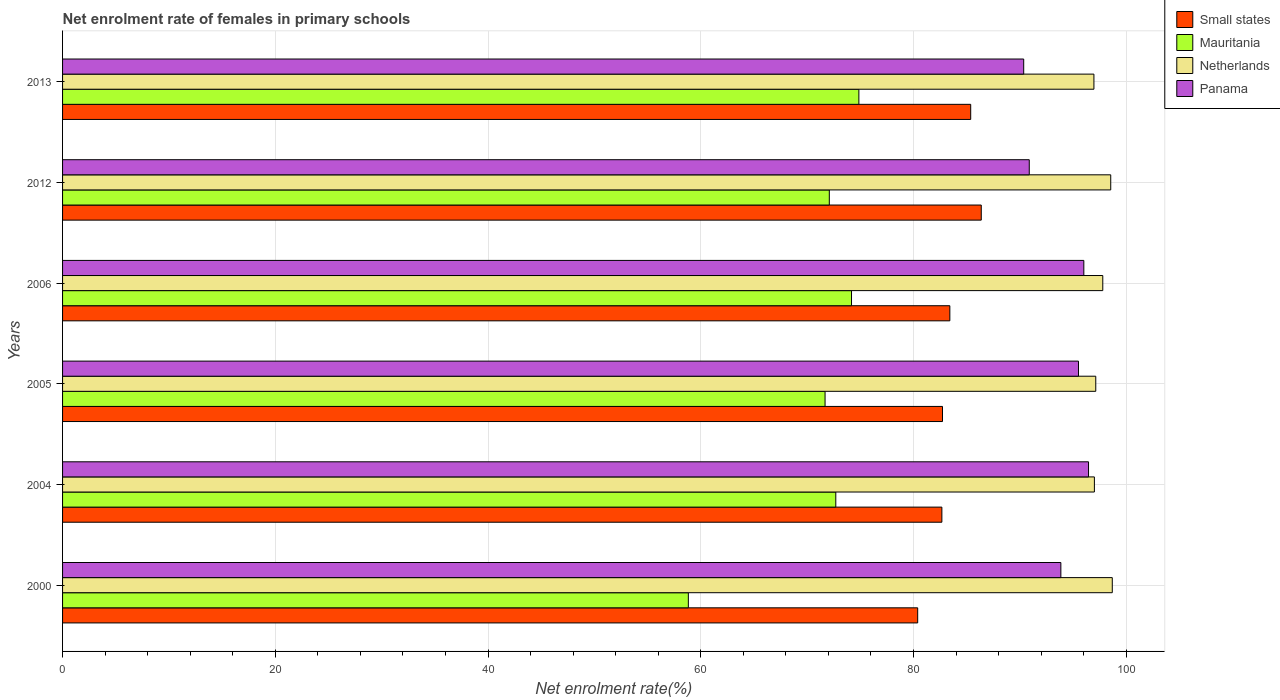How many different coloured bars are there?
Offer a terse response. 4. How many bars are there on the 5th tick from the top?
Provide a succinct answer. 4. How many bars are there on the 5th tick from the bottom?
Keep it short and to the point. 4. In how many cases, is the number of bars for a given year not equal to the number of legend labels?
Your response must be concise. 0. What is the net enrolment rate of females in primary schools in Small states in 2004?
Give a very brief answer. 82.67. Across all years, what is the maximum net enrolment rate of females in primary schools in Panama?
Your answer should be compact. 96.46. Across all years, what is the minimum net enrolment rate of females in primary schools in Netherlands?
Offer a terse response. 96.97. What is the total net enrolment rate of females in primary schools in Panama in the graph?
Ensure brevity in your answer.  563.11. What is the difference between the net enrolment rate of females in primary schools in Panama in 2004 and that in 2012?
Your answer should be very brief. 5.57. What is the difference between the net enrolment rate of females in primary schools in Panama in 2004 and the net enrolment rate of females in primary schools in Small states in 2005?
Offer a very short reply. 13.73. What is the average net enrolment rate of females in primary schools in Panama per year?
Keep it short and to the point. 93.85. In the year 2013, what is the difference between the net enrolment rate of females in primary schools in Netherlands and net enrolment rate of females in primary schools in Small states?
Offer a very short reply. 11.59. What is the ratio of the net enrolment rate of females in primary schools in Panama in 2012 to that in 2013?
Your answer should be very brief. 1.01. What is the difference between the highest and the second highest net enrolment rate of females in primary schools in Small states?
Provide a succinct answer. 0.99. What is the difference between the highest and the lowest net enrolment rate of females in primary schools in Small states?
Your answer should be very brief. 5.98. In how many years, is the net enrolment rate of females in primary schools in Small states greater than the average net enrolment rate of females in primary schools in Small states taken over all years?
Keep it short and to the point. 2. What does the 1st bar from the top in 2000 represents?
Your response must be concise. Panama. What does the 3rd bar from the bottom in 2013 represents?
Offer a terse response. Netherlands. How many bars are there?
Your answer should be compact. 24. How many years are there in the graph?
Ensure brevity in your answer.  6. Does the graph contain any zero values?
Ensure brevity in your answer.  No. Does the graph contain grids?
Provide a succinct answer. Yes. Where does the legend appear in the graph?
Offer a very short reply. Top right. How many legend labels are there?
Offer a very short reply. 4. How are the legend labels stacked?
Make the answer very short. Vertical. What is the title of the graph?
Keep it short and to the point. Net enrolment rate of females in primary schools. What is the label or title of the X-axis?
Make the answer very short. Net enrolment rate(%). What is the Net enrolment rate(%) in Small states in 2000?
Offer a very short reply. 80.4. What is the Net enrolment rate(%) of Mauritania in 2000?
Provide a short and direct response. 58.84. What is the Net enrolment rate(%) in Netherlands in 2000?
Provide a short and direct response. 98.69. What is the Net enrolment rate(%) in Panama in 2000?
Ensure brevity in your answer.  93.86. What is the Net enrolment rate(%) in Small states in 2004?
Make the answer very short. 82.67. What is the Net enrolment rate(%) in Mauritania in 2004?
Ensure brevity in your answer.  72.7. What is the Net enrolment rate(%) in Netherlands in 2004?
Offer a terse response. 97.01. What is the Net enrolment rate(%) in Panama in 2004?
Offer a terse response. 96.46. What is the Net enrolment rate(%) in Small states in 2005?
Give a very brief answer. 82.73. What is the Net enrolment rate(%) of Mauritania in 2005?
Ensure brevity in your answer.  71.69. What is the Net enrolment rate(%) in Netherlands in 2005?
Your answer should be compact. 97.14. What is the Net enrolment rate(%) of Panama in 2005?
Provide a succinct answer. 95.52. What is the Net enrolment rate(%) of Small states in 2006?
Ensure brevity in your answer.  83.42. What is the Net enrolment rate(%) of Mauritania in 2006?
Offer a very short reply. 74.18. What is the Net enrolment rate(%) in Netherlands in 2006?
Ensure brevity in your answer.  97.8. What is the Net enrolment rate(%) in Panama in 2006?
Ensure brevity in your answer.  96.02. What is the Net enrolment rate(%) of Small states in 2012?
Keep it short and to the point. 86.37. What is the Net enrolment rate(%) in Mauritania in 2012?
Offer a terse response. 72.09. What is the Net enrolment rate(%) in Netherlands in 2012?
Provide a short and direct response. 98.55. What is the Net enrolment rate(%) in Panama in 2012?
Provide a short and direct response. 90.89. What is the Net enrolment rate(%) in Small states in 2013?
Provide a short and direct response. 85.38. What is the Net enrolment rate(%) in Mauritania in 2013?
Your answer should be compact. 74.87. What is the Net enrolment rate(%) of Netherlands in 2013?
Make the answer very short. 96.97. What is the Net enrolment rate(%) in Panama in 2013?
Give a very brief answer. 90.37. Across all years, what is the maximum Net enrolment rate(%) in Small states?
Your answer should be compact. 86.37. Across all years, what is the maximum Net enrolment rate(%) of Mauritania?
Ensure brevity in your answer.  74.87. Across all years, what is the maximum Net enrolment rate(%) of Netherlands?
Ensure brevity in your answer.  98.69. Across all years, what is the maximum Net enrolment rate(%) in Panama?
Provide a succinct answer. 96.46. Across all years, what is the minimum Net enrolment rate(%) in Small states?
Keep it short and to the point. 80.4. Across all years, what is the minimum Net enrolment rate(%) of Mauritania?
Offer a very short reply. 58.84. Across all years, what is the minimum Net enrolment rate(%) of Netherlands?
Your answer should be very brief. 96.97. Across all years, what is the minimum Net enrolment rate(%) of Panama?
Give a very brief answer. 90.37. What is the total Net enrolment rate(%) of Small states in the graph?
Your response must be concise. 500.98. What is the total Net enrolment rate(%) of Mauritania in the graph?
Your response must be concise. 424.36. What is the total Net enrolment rate(%) of Netherlands in the graph?
Offer a very short reply. 586.16. What is the total Net enrolment rate(%) in Panama in the graph?
Your answer should be compact. 563.11. What is the difference between the Net enrolment rate(%) of Small states in 2000 and that in 2004?
Give a very brief answer. -2.27. What is the difference between the Net enrolment rate(%) of Mauritania in 2000 and that in 2004?
Make the answer very short. -13.86. What is the difference between the Net enrolment rate(%) of Netherlands in 2000 and that in 2004?
Give a very brief answer. 1.68. What is the difference between the Net enrolment rate(%) of Panama in 2000 and that in 2004?
Make the answer very short. -2.6. What is the difference between the Net enrolment rate(%) in Small states in 2000 and that in 2005?
Give a very brief answer. -2.33. What is the difference between the Net enrolment rate(%) of Mauritania in 2000 and that in 2005?
Keep it short and to the point. -12.85. What is the difference between the Net enrolment rate(%) of Netherlands in 2000 and that in 2005?
Give a very brief answer. 1.55. What is the difference between the Net enrolment rate(%) of Panama in 2000 and that in 2005?
Your answer should be compact. -1.66. What is the difference between the Net enrolment rate(%) of Small states in 2000 and that in 2006?
Your answer should be compact. -3.02. What is the difference between the Net enrolment rate(%) in Mauritania in 2000 and that in 2006?
Offer a terse response. -15.34. What is the difference between the Net enrolment rate(%) in Netherlands in 2000 and that in 2006?
Provide a succinct answer. 0.89. What is the difference between the Net enrolment rate(%) in Panama in 2000 and that in 2006?
Make the answer very short. -2.16. What is the difference between the Net enrolment rate(%) of Small states in 2000 and that in 2012?
Your answer should be compact. -5.98. What is the difference between the Net enrolment rate(%) of Mauritania in 2000 and that in 2012?
Your answer should be very brief. -13.25. What is the difference between the Net enrolment rate(%) in Netherlands in 2000 and that in 2012?
Your answer should be very brief. 0.15. What is the difference between the Net enrolment rate(%) of Panama in 2000 and that in 2012?
Keep it short and to the point. 2.97. What is the difference between the Net enrolment rate(%) in Small states in 2000 and that in 2013?
Make the answer very short. -4.98. What is the difference between the Net enrolment rate(%) in Mauritania in 2000 and that in 2013?
Provide a succinct answer. -16.03. What is the difference between the Net enrolment rate(%) in Netherlands in 2000 and that in 2013?
Your response must be concise. 1.73. What is the difference between the Net enrolment rate(%) of Panama in 2000 and that in 2013?
Your response must be concise. 3.49. What is the difference between the Net enrolment rate(%) in Small states in 2004 and that in 2005?
Your answer should be very brief. -0.06. What is the difference between the Net enrolment rate(%) of Mauritania in 2004 and that in 2005?
Provide a short and direct response. 1.01. What is the difference between the Net enrolment rate(%) of Netherlands in 2004 and that in 2005?
Your answer should be very brief. -0.13. What is the difference between the Net enrolment rate(%) of Small states in 2004 and that in 2006?
Make the answer very short. -0.75. What is the difference between the Net enrolment rate(%) of Mauritania in 2004 and that in 2006?
Your response must be concise. -1.48. What is the difference between the Net enrolment rate(%) in Netherlands in 2004 and that in 2006?
Your answer should be compact. -0.79. What is the difference between the Net enrolment rate(%) in Panama in 2004 and that in 2006?
Offer a very short reply. 0.44. What is the difference between the Net enrolment rate(%) of Small states in 2004 and that in 2012?
Your answer should be very brief. -3.7. What is the difference between the Net enrolment rate(%) in Mauritania in 2004 and that in 2012?
Your answer should be compact. 0.61. What is the difference between the Net enrolment rate(%) of Netherlands in 2004 and that in 2012?
Keep it short and to the point. -1.54. What is the difference between the Net enrolment rate(%) of Panama in 2004 and that in 2012?
Your answer should be very brief. 5.57. What is the difference between the Net enrolment rate(%) of Small states in 2004 and that in 2013?
Give a very brief answer. -2.71. What is the difference between the Net enrolment rate(%) in Mauritania in 2004 and that in 2013?
Provide a succinct answer. -2.17. What is the difference between the Net enrolment rate(%) of Netherlands in 2004 and that in 2013?
Offer a very short reply. 0.04. What is the difference between the Net enrolment rate(%) of Panama in 2004 and that in 2013?
Your answer should be very brief. 6.09. What is the difference between the Net enrolment rate(%) in Small states in 2005 and that in 2006?
Make the answer very short. -0.69. What is the difference between the Net enrolment rate(%) in Mauritania in 2005 and that in 2006?
Provide a succinct answer. -2.49. What is the difference between the Net enrolment rate(%) of Netherlands in 2005 and that in 2006?
Your response must be concise. -0.66. What is the difference between the Net enrolment rate(%) in Panama in 2005 and that in 2006?
Give a very brief answer. -0.5. What is the difference between the Net enrolment rate(%) in Small states in 2005 and that in 2012?
Your answer should be very brief. -3.64. What is the difference between the Net enrolment rate(%) of Mauritania in 2005 and that in 2012?
Give a very brief answer. -0.4. What is the difference between the Net enrolment rate(%) of Netherlands in 2005 and that in 2012?
Offer a terse response. -1.41. What is the difference between the Net enrolment rate(%) of Panama in 2005 and that in 2012?
Keep it short and to the point. 4.63. What is the difference between the Net enrolment rate(%) in Small states in 2005 and that in 2013?
Keep it short and to the point. -2.65. What is the difference between the Net enrolment rate(%) of Mauritania in 2005 and that in 2013?
Ensure brevity in your answer.  -3.18. What is the difference between the Net enrolment rate(%) of Netherlands in 2005 and that in 2013?
Give a very brief answer. 0.17. What is the difference between the Net enrolment rate(%) of Panama in 2005 and that in 2013?
Give a very brief answer. 5.15. What is the difference between the Net enrolment rate(%) of Small states in 2006 and that in 2012?
Offer a terse response. -2.95. What is the difference between the Net enrolment rate(%) in Mauritania in 2006 and that in 2012?
Offer a terse response. 2.09. What is the difference between the Net enrolment rate(%) of Netherlands in 2006 and that in 2012?
Give a very brief answer. -0.75. What is the difference between the Net enrolment rate(%) of Panama in 2006 and that in 2012?
Ensure brevity in your answer.  5.13. What is the difference between the Net enrolment rate(%) in Small states in 2006 and that in 2013?
Ensure brevity in your answer.  -1.96. What is the difference between the Net enrolment rate(%) of Mauritania in 2006 and that in 2013?
Give a very brief answer. -0.69. What is the difference between the Net enrolment rate(%) of Netherlands in 2006 and that in 2013?
Make the answer very short. 0.83. What is the difference between the Net enrolment rate(%) of Panama in 2006 and that in 2013?
Keep it short and to the point. 5.65. What is the difference between the Net enrolment rate(%) of Mauritania in 2012 and that in 2013?
Provide a succinct answer. -2.78. What is the difference between the Net enrolment rate(%) in Netherlands in 2012 and that in 2013?
Keep it short and to the point. 1.58. What is the difference between the Net enrolment rate(%) of Panama in 2012 and that in 2013?
Offer a very short reply. 0.52. What is the difference between the Net enrolment rate(%) in Small states in 2000 and the Net enrolment rate(%) in Mauritania in 2004?
Make the answer very short. 7.7. What is the difference between the Net enrolment rate(%) in Small states in 2000 and the Net enrolment rate(%) in Netherlands in 2004?
Keep it short and to the point. -16.61. What is the difference between the Net enrolment rate(%) in Small states in 2000 and the Net enrolment rate(%) in Panama in 2004?
Make the answer very short. -16.06. What is the difference between the Net enrolment rate(%) of Mauritania in 2000 and the Net enrolment rate(%) of Netherlands in 2004?
Give a very brief answer. -38.18. What is the difference between the Net enrolment rate(%) in Mauritania in 2000 and the Net enrolment rate(%) in Panama in 2004?
Your response must be concise. -37.62. What is the difference between the Net enrolment rate(%) in Netherlands in 2000 and the Net enrolment rate(%) in Panama in 2004?
Your response must be concise. 2.23. What is the difference between the Net enrolment rate(%) of Small states in 2000 and the Net enrolment rate(%) of Mauritania in 2005?
Your answer should be compact. 8.71. What is the difference between the Net enrolment rate(%) of Small states in 2000 and the Net enrolment rate(%) of Netherlands in 2005?
Make the answer very short. -16.74. What is the difference between the Net enrolment rate(%) in Small states in 2000 and the Net enrolment rate(%) in Panama in 2005?
Provide a succinct answer. -15.12. What is the difference between the Net enrolment rate(%) in Mauritania in 2000 and the Net enrolment rate(%) in Netherlands in 2005?
Provide a short and direct response. -38.31. What is the difference between the Net enrolment rate(%) of Mauritania in 2000 and the Net enrolment rate(%) of Panama in 2005?
Offer a very short reply. -36.68. What is the difference between the Net enrolment rate(%) of Netherlands in 2000 and the Net enrolment rate(%) of Panama in 2005?
Your response must be concise. 3.18. What is the difference between the Net enrolment rate(%) of Small states in 2000 and the Net enrolment rate(%) of Mauritania in 2006?
Give a very brief answer. 6.22. What is the difference between the Net enrolment rate(%) in Small states in 2000 and the Net enrolment rate(%) in Netherlands in 2006?
Make the answer very short. -17.4. What is the difference between the Net enrolment rate(%) in Small states in 2000 and the Net enrolment rate(%) in Panama in 2006?
Offer a very short reply. -15.62. What is the difference between the Net enrolment rate(%) of Mauritania in 2000 and the Net enrolment rate(%) of Netherlands in 2006?
Provide a short and direct response. -38.97. What is the difference between the Net enrolment rate(%) in Mauritania in 2000 and the Net enrolment rate(%) in Panama in 2006?
Your response must be concise. -37.18. What is the difference between the Net enrolment rate(%) in Netherlands in 2000 and the Net enrolment rate(%) in Panama in 2006?
Your answer should be compact. 2.68. What is the difference between the Net enrolment rate(%) of Small states in 2000 and the Net enrolment rate(%) of Mauritania in 2012?
Make the answer very short. 8.31. What is the difference between the Net enrolment rate(%) of Small states in 2000 and the Net enrolment rate(%) of Netherlands in 2012?
Provide a succinct answer. -18.15. What is the difference between the Net enrolment rate(%) in Small states in 2000 and the Net enrolment rate(%) in Panama in 2012?
Offer a very short reply. -10.49. What is the difference between the Net enrolment rate(%) in Mauritania in 2000 and the Net enrolment rate(%) in Netherlands in 2012?
Your answer should be very brief. -39.71. What is the difference between the Net enrolment rate(%) of Mauritania in 2000 and the Net enrolment rate(%) of Panama in 2012?
Provide a short and direct response. -32.05. What is the difference between the Net enrolment rate(%) of Netherlands in 2000 and the Net enrolment rate(%) of Panama in 2012?
Ensure brevity in your answer.  7.81. What is the difference between the Net enrolment rate(%) in Small states in 2000 and the Net enrolment rate(%) in Mauritania in 2013?
Provide a succinct answer. 5.53. What is the difference between the Net enrolment rate(%) of Small states in 2000 and the Net enrolment rate(%) of Netherlands in 2013?
Make the answer very short. -16.57. What is the difference between the Net enrolment rate(%) in Small states in 2000 and the Net enrolment rate(%) in Panama in 2013?
Your answer should be very brief. -9.97. What is the difference between the Net enrolment rate(%) in Mauritania in 2000 and the Net enrolment rate(%) in Netherlands in 2013?
Ensure brevity in your answer.  -38.13. What is the difference between the Net enrolment rate(%) in Mauritania in 2000 and the Net enrolment rate(%) in Panama in 2013?
Keep it short and to the point. -31.53. What is the difference between the Net enrolment rate(%) in Netherlands in 2000 and the Net enrolment rate(%) in Panama in 2013?
Your answer should be compact. 8.33. What is the difference between the Net enrolment rate(%) in Small states in 2004 and the Net enrolment rate(%) in Mauritania in 2005?
Provide a short and direct response. 10.98. What is the difference between the Net enrolment rate(%) in Small states in 2004 and the Net enrolment rate(%) in Netherlands in 2005?
Your answer should be compact. -14.47. What is the difference between the Net enrolment rate(%) of Small states in 2004 and the Net enrolment rate(%) of Panama in 2005?
Your answer should be very brief. -12.84. What is the difference between the Net enrolment rate(%) of Mauritania in 2004 and the Net enrolment rate(%) of Netherlands in 2005?
Your response must be concise. -24.44. What is the difference between the Net enrolment rate(%) of Mauritania in 2004 and the Net enrolment rate(%) of Panama in 2005?
Ensure brevity in your answer.  -22.82. What is the difference between the Net enrolment rate(%) of Netherlands in 2004 and the Net enrolment rate(%) of Panama in 2005?
Make the answer very short. 1.5. What is the difference between the Net enrolment rate(%) of Small states in 2004 and the Net enrolment rate(%) of Mauritania in 2006?
Provide a short and direct response. 8.5. What is the difference between the Net enrolment rate(%) in Small states in 2004 and the Net enrolment rate(%) in Netherlands in 2006?
Offer a terse response. -15.13. What is the difference between the Net enrolment rate(%) of Small states in 2004 and the Net enrolment rate(%) of Panama in 2006?
Your answer should be compact. -13.35. What is the difference between the Net enrolment rate(%) of Mauritania in 2004 and the Net enrolment rate(%) of Netherlands in 2006?
Your answer should be compact. -25.1. What is the difference between the Net enrolment rate(%) of Mauritania in 2004 and the Net enrolment rate(%) of Panama in 2006?
Offer a very short reply. -23.32. What is the difference between the Net enrolment rate(%) in Netherlands in 2004 and the Net enrolment rate(%) in Panama in 2006?
Keep it short and to the point. 0.99. What is the difference between the Net enrolment rate(%) of Small states in 2004 and the Net enrolment rate(%) of Mauritania in 2012?
Make the answer very short. 10.58. What is the difference between the Net enrolment rate(%) in Small states in 2004 and the Net enrolment rate(%) in Netherlands in 2012?
Provide a short and direct response. -15.88. What is the difference between the Net enrolment rate(%) of Small states in 2004 and the Net enrolment rate(%) of Panama in 2012?
Give a very brief answer. -8.22. What is the difference between the Net enrolment rate(%) of Mauritania in 2004 and the Net enrolment rate(%) of Netherlands in 2012?
Offer a terse response. -25.85. What is the difference between the Net enrolment rate(%) in Mauritania in 2004 and the Net enrolment rate(%) in Panama in 2012?
Keep it short and to the point. -18.19. What is the difference between the Net enrolment rate(%) in Netherlands in 2004 and the Net enrolment rate(%) in Panama in 2012?
Ensure brevity in your answer.  6.12. What is the difference between the Net enrolment rate(%) in Small states in 2004 and the Net enrolment rate(%) in Mauritania in 2013?
Your response must be concise. 7.8. What is the difference between the Net enrolment rate(%) of Small states in 2004 and the Net enrolment rate(%) of Netherlands in 2013?
Offer a very short reply. -14.3. What is the difference between the Net enrolment rate(%) in Small states in 2004 and the Net enrolment rate(%) in Panama in 2013?
Offer a very short reply. -7.69. What is the difference between the Net enrolment rate(%) of Mauritania in 2004 and the Net enrolment rate(%) of Netherlands in 2013?
Make the answer very short. -24.27. What is the difference between the Net enrolment rate(%) in Mauritania in 2004 and the Net enrolment rate(%) in Panama in 2013?
Ensure brevity in your answer.  -17.67. What is the difference between the Net enrolment rate(%) of Netherlands in 2004 and the Net enrolment rate(%) of Panama in 2013?
Keep it short and to the point. 6.65. What is the difference between the Net enrolment rate(%) of Small states in 2005 and the Net enrolment rate(%) of Mauritania in 2006?
Your answer should be very brief. 8.55. What is the difference between the Net enrolment rate(%) in Small states in 2005 and the Net enrolment rate(%) in Netherlands in 2006?
Keep it short and to the point. -15.07. What is the difference between the Net enrolment rate(%) of Small states in 2005 and the Net enrolment rate(%) of Panama in 2006?
Offer a very short reply. -13.29. What is the difference between the Net enrolment rate(%) of Mauritania in 2005 and the Net enrolment rate(%) of Netherlands in 2006?
Offer a terse response. -26.11. What is the difference between the Net enrolment rate(%) in Mauritania in 2005 and the Net enrolment rate(%) in Panama in 2006?
Offer a terse response. -24.33. What is the difference between the Net enrolment rate(%) of Netherlands in 2005 and the Net enrolment rate(%) of Panama in 2006?
Offer a very short reply. 1.12. What is the difference between the Net enrolment rate(%) in Small states in 2005 and the Net enrolment rate(%) in Mauritania in 2012?
Keep it short and to the point. 10.64. What is the difference between the Net enrolment rate(%) of Small states in 2005 and the Net enrolment rate(%) of Netherlands in 2012?
Offer a terse response. -15.82. What is the difference between the Net enrolment rate(%) in Small states in 2005 and the Net enrolment rate(%) in Panama in 2012?
Provide a succinct answer. -8.16. What is the difference between the Net enrolment rate(%) of Mauritania in 2005 and the Net enrolment rate(%) of Netherlands in 2012?
Provide a short and direct response. -26.86. What is the difference between the Net enrolment rate(%) in Mauritania in 2005 and the Net enrolment rate(%) in Panama in 2012?
Your answer should be compact. -19.2. What is the difference between the Net enrolment rate(%) of Netherlands in 2005 and the Net enrolment rate(%) of Panama in 2012?
Offer a very short reply. 6.25. What is the difference between the Net enrolment rate(%) in Small states in 2005 and the Net enrolment rate(%) in Mauritania in 2013?
Give a very brief answer. 7.86. What is the difference between the Net enrolment rate(%) in Small states in 2005 and the Net enrolment rate(%) in Netherlands in 2013?
Your response must be concise. -14.24. What is the difference between the Net enrolment rate(%) of Small states in 2005 and the Net enrolment rate(%) of Panama in 2013?
Keep it short and to the point. -7.63. What is the difference between the Net enrolment rate(%) in Mauritania in 2005 and the Net enrolment rate(%) in Netherlands in 2013?
Provide a succinct answer. -25.28. What is the difference between the Net enrolment rate(%) in Mauritania in 2005 and the Net enrolment rate(%) in Panama in 2013?
Give a very brief answer. -18.68. What is the difference between the Net enrolment rate(%) of Netherlands in 2005 and the Net enrolment rate(%) of Panama in 2013?
Your answer should be compact. 6.78. What is the difference between the Net enrolment rate(%) in Small states in 2006 and the Net enrolment rate(%) in Mauritania in 2012?
Provide a succinct answer. 11.33. What is the difference between the Net enrolment rate(%) of Small states in 2006 and the Net enrolment rate(%) of Netherlands in 2012?
Make the answer very short. -15.13. What is the difference between the Net enrolment rate(%) in Small states in 2006 and the Net enrolment rate(%) in Panama in 2012?
Your answer should be compact. -7.47. What is the difference between the Net enrolment rate(%) of Mauritania in 2006 and the Net enrolment rate(%) of Netherlands in 2012?
Make the answer very short. -24.37. What is the difference between the Net enrolment rate(%) of Mauritania in 2006 and the Net enrolment rate(%) of Panama in 2012?
Provide a short and direct response. -16.71. What is the difference between the Net enrolment rate(%) in Netherlands in 2006 and the Net enrolment rate(%) in Panama in 2012?
Your answer should be very brief. 6.91. What is the difference between the Net enrolment rate(%) in Small states in 2006 and the Net enrolment rate(%) in Mauritania in 2013?
Provide a succinct answer. 8.55. What is the difference between the Net enrolment rate(%) of Small states in 2006 and the Net enrolment rate(%) of Netherlands in 2013?
Provide a short and direct response. -13.55. What is the difference between the Net enrolment rate(%) of Small states in 2006 and the Net enrolment rate(%) of Panama in 2013?
Offer a terse response. -6.94. What is the difference between the Net enrolment rate(%) of Mauritania in 2006 and the Net enrolment rate(%) of Netherlands in 2013?
Your answer should be compact. -22.79. What is the difference between the Net enrolment rate(%) of Mauritania in 2006 and the Net enrolment rate(%) of Panama in 2013?
Keep it short and to the point. -16.19. What is the difference between the Net enrolment rate(%) in Netherlands in 2006 and the Net enrolment rate(%) in Panama in 2013?
Offer a very short reply. 7.44. What is the difference between the Net enrolment rate(%) of Small states in 2012 and the Net enrolment rate(%) of Mauritania in 2013?
Give a very brief answer. 11.51. What is the difference between the Net enrolment rate(%) in Small states in 2012 and the Net enrolment rate(%) in Netherlands in 2013?
Offer a very short reply. -10.59. What is the difference between the Net enrolment rate(%) in Small states in 2012 and the Net enrolment rate(%) in Panama in 2013?
Provide a succinct answer. -3.99. What is the difference between the Net enrolment rate(%) in Mauritania in 2012 and the Net enrolment rate(%) in Netherlands in 2013?
Your answer should be compact. -24.88. What is the difference between the Net enrolment rate(%) in Mauritania in 2012 and the Net enrolment rate(%) in Panama in 2013?
Your response must be concise. -18.28. What is the difference between the Net enrolment rate(%) in Netherlands in 2012 and the Net enrolment rate(%) in Panama in 2013?
Give a very brief answer. 8.18. What is the average Net enrolment rate(%) in Small states per year?
Offer a terse response. 83.5. What is the average Net enrolment rate(%) in Mauritania per year?
Offer a terse response. 70.73. What is the average Net enrolment rate(%) in Netherlands per year?
Offer a very short reply. 97.69. What is the average Net enrolment rate(%) of Panama per year?
Keep it short and to the point. 93.85. In the year 2000, what is the difference between the Net enrolment rate(%) of Small states and Net enrolment rate(%) of Mauritania?
Keep it short and to the point. 21.56. In the year 2000, what is the difference between the Net enrolment rate(%) of Small states and Net enrolment rate(%) of Netherlands?
Give a very brief answer. -18.3. In the year 2000, what is the difference between the Net enrolment rate(%) of Small states and Net enrolment rate(%) of Panama?
Keep it short and to the point. -13.46. In the year 2000, what is the difference between the Net enrolment rate(%) of Mauritania and Net enrolment rate(%) of Netherlands?
Make the answer very short. -39.86. In the year 2000, what is the difference between the Net enrolment rate(%) of Mauritania and Net enrolment rate(%) of Panama?
Make the answer very short. -35.02. In the year 2000, what is the difference between the Net enrolment rate(%) in Netherlands and Net enrolment rate(%) in Panama?
Your answer should be very brief. 4.84. In the year 2004, what is the difference between the Net enrolment rate(%) of Small states and Net enrolment rate(%) of Mauritania?
Your answer should be very brief. 9.97. In the year 2004, what is the difference between the Net enrolment rate(%) of Small states and Net enrolment rate(%) of Netherlands?
Your response must be concise. -14.34. In the year 2004, what is the difference between the Net enrolment rate(%) in Small states and Net enrolment rate(%) in Panama?
Give a very brief answer. -13.79. In the year 2004, what is the difference between the Net enrolment rate(%) in Mauritania and Net enrolment rate(%) in Netherlands?
Ensure brevity in your answer.  -24.31. In the year 2004, what is the difference between the Net enrolment rate(%) of Mauritania and Net enrolment rate(%) of Panama?
Provide a succinct answer. -23.76. In the year 2004, what is the difference between the Net enrolment rate(%) of Netherlands and Net enrolment rate(%) of Panama?
Offer a terse response. 0.55. In the year 2005, what is the difference between the Net enrolment rate(%) of Small states and Net enrolment rate(%) of Mauritania?
Give a very brief answer. 11.04. In the year 2005, what is the difference between the Net enrolment rate(%) in Small states and Net enrolment rate(%) in Netherlands?
Offer a very short reply. -14.41. In the year 2005, what is the difference between the Net enrolment rate(%) of Small states and Net enrolment rate(%) of Panama?
Provide a succinct answer. -12.79. In the year 2005, what is the difference between the Net enrolment rate(%) of Mauritania and Net enrolment rate(%) of Netherlands?
Offer a terse response. -25.45. In the year 2005, what is the difference between the Net enrolment rate(%) of Mauritania and Net enrolment rate(%) of Panama?
Your answer should be very brief. -23.83. In the year 2005, what is the difference between the Net enrolment rate(%) of Netherlands and Net enrolment rate(%) of Panama?
Your response must be concise. 1.63. In the year 2006, what is the difference between the Net enrolment rate(%) of Small states and Net enrolment rate(%) of Mauritania?
Make the answer very short. 9.25. In the year 2006, what is the difference between the Net enrolment rate(%) in Small states and Net enrolment rate(%) in Netherlands?
Provide a succinct answer. -14.38. In the year 2006, what is the difference between the Net enrolment rate(%) of Small states and Net enrolment rate(%) of Panama?
Ensure brevity in your answer.  -12.6. In the year 2006, what is the difference between the Net enrolment rate(%) in Mauritania and Net enrolment rate(%) in Netherlands?
Offer a terse response. -23.62. In the year 2006, what is the difference between the Net enrolment rate(%) in Mauritania and Net enrolment rate(%) in Panama?
Offer a terse response. -21.84. In the year 2006, what is the difference between the Net enrolment rate(%) in Netherlands and Net enrolment rate(%) in Panama?
Ensure brevity in your answer.  1.78. In the year 2012, what is the difference between the Net enrolment rate(%) in Small states and Net enrolment rate(%) in Mauritania?
Give a very brief answer. 14.29. In the year 2012, what is the difference between the Net enrolment rate(%) in Small states and Net enrolment rate(%) in Netherlands?
Provide a succinct answer. -12.17. In the year 2012, what is the difference between the Net enrolment rate(%) in Small states and Net enrolment rate(%) in Panama?
Provide a succinct answer. -4.51. In the year 2012, what is the difference between the Net enrolment rate(%) of Mauritania and Net enrolment rate(%) of Netherlands?
Ensure brevity in your answer.  -26.46. In the year 2012, what is the difference between the Net enrolment rate(%) of Mauritania and Net enrolment rate(%) of Panama?
Make the answer very short. -18.8. In the year 2012, what is the difference between the Net enrolment rate(%) in Netherlands and Net enrolment rate(%) in Panama?
Provide a succinct answer. 7.66. In the year 2013, what is the difference between the Net enrolment rate(%) in Small states and Net enrolment rate(%) in Mauritania?
Give a very brief answer. 10.51. In the year 2013, what is the difference between the Net enrolment rate(%) of Small states and Net enrolment rate(%) of Netherlands?
Your answer should be very brief. -11.59. In the year 2013, what is the difference between the Net enrolment rate(%) of Small states and Net enrolment rate(%) of Panama?
Your answer should be compact. -4.98. In the year 2013, what is the difference between the Net enrolment rate(%) in Mauritania and Net enrolment rate(%) in Netherlands?
Provide a short and direct response. -22.1. In the year 2013, what is the difference between the Net enrolment rate(%) in Mauritania and Net enrolment rate(%) in Panama?
Provide a short and direct response. -15.5. In the year 2013, what is the difference between the Net enrolment rate(%) in Netherlands and Net enrolment rate(%) in Panama?
Give a very brief answer. 6.6. What is the ratio of the Net enrolment rate(%) of Small states in 2000 to that in 2004?
Provide a succinct answer. 0.97. What is the ratio of the Net enrolment rate(%) of Mauritania in 2000 to that in 2004?
Ensure brevity in your answer.  0.81. What is the ratio of the Net enrolment rate(%) of Netherlands in 2000 to that in 2004?
Provide a succinct answer. 1.02. What is the ratio of the Net enrolment rate(%) in Small states in 2000 to that in 2005?
Offer a terse response. 0.97. What is the ratio of the Net enrolment rate(%) in Mauritania in 2000 to that in 2005?
Your response must be concise. 0.82. What is the ratio of the Net enrolment rate(%) of Netherlands in 2000 to that in 2005?
Offer a terse response. 1.02. What is the ratio of the Net enrolment rate(%) of Panama in 2000 to that in 2005?
Your response must be concise. 0.98. What is the ratio of the Net enrolment rate(%) in Small states in 2000 to that in 2006?
Offer a terse response. 0.96. What is the ratio of the Net enrolment rate(%) in Mauritania in 2000 to that in 2006?
Your response must be concise. 0.79. What is the ratio of the Net enrolment rate(%) of Netherlands in 2000 to that in 2006?
Ensure brevity in your answer.  1.01. What is the ratio of the Net enrolment rate(%) of Panama in 2000 to that in 2006?
Your answer should be compact. 0.98. What is the ratio of the Net enrolment rate(%) in Small states in 2000 to that in 2012?
Provide a succinct answer. 0.93. What is the ratio of the Net enrolment rate(%) in Mauritania in 2000 to that in 2012?
Your answer should be very brief. 0.82. What is the ratio of the Net enrolment rate(%) of Panama in 2000 to that in 2012?
Your answer should be very brief. 1.03. What is the ratio of the Net enrolment rate(%) in Small states in 2000 to that in 2013?
Your answer should be compact. 0.94. What is the ratio of the Net enrolment rate(%) in Mauritania in 2000 to that in 2013?
Offer a very short reply. 0.79. What is the ratio of the Net enrolment rate(%) in Netherlands in 2000 to that in 2013?
Make the answer very short. 1.02. What is the ratio of the Net enrolment rate(%) of Panama in 2000 to that in 2013?
Provide a succinct answer. 1.04. What is the ratio of the Net enrolment rate(%) in Mauritania in 2004 to that in 2005?
Your answer should be very brief. 1.01. What is the ratio of the Net enrolment rate(%) in Netherlands in 2004 to that in 2005?
Offer a terse response. 1. What is the ratio of the Net enrolment rate(%) in Panama in 2004 to that in 2005?
Keep it short and to the point. 1.01. What is the ratio of the Net enrolment rate(%) in Mauritania in 2004 to that in 2006?
Your answer should be very brief. 0.98. What is the ratio of the Net enrolment rate(%) of Small states in 2004 to that in 2012?
Give a very brief answer. 0.96. What is the ratio of the Net enrolment rate(%) in Mauritania in 2004 to that in 2012?
Your answer should be compact. 1.01. What is the ratio of the Net enrolment rate(%) in Netherlands in 2004 to that in 2012?
Provide a succinct answer. 0.98. What is the ratio of the Net enrolment rate(%) of Panama in 2004 to that in 2012?
Provide a short and direct response. 1.06. What is the ratio of the Net enrolment rate(%) in Small states in 2004 to that in 2013?
Keep it short and to the point. 0.97. What is the ratio of the Net enrolment rate(%) in Netherlands in 2004 to that in 2013?
Keep it short and to the point. 1. What is the ratio of the Net enrolment rate(%) of Panama in 2004 to that in 2013?
Give a very brief answer. 1.07. What is the ratio of the Net enrolment rate(%) in Small states in 2005 to that in 2006?
Offer a terse response. 0.99. What is the ratio of the Net enrolment rate(%) in Mauritania in 2005 to that in 2006?
Offer a terse response. 0.97. What is the ratio of the Net enrolment rate(%) of Small states in 2005 to that in 2012?
Ensure brevity in your answer.  0.96. What is the ratio of the Net enrolment rate(%) in Mauritania in 2005 to that in 2012?
Your answer should be very brief. 0.99. What is the ratio of the Net enrolment rate(%) in Netherlands in 2005 to that in 2012?
Your response must be concise. 0.99. What is the ratio of the Net enrolment rate(%) of Panama in 2005 to that in 2012?
Make the answer very short. 1.05. What is the ratio of the Net enrolment rate(%) of Small states in 2005 to that in 2013?
Make the answer very short. 0.97. What is the ratio of the Net enrolment rate(%) of Mauritania in 2005 to that in 2013?
Provide a short and direct response. 0.96. What is the ratio of the Net enrolment rate(%) in Netherlands in 2005 to that in 2013?
Your response must be concise. 1. What is the ratio of the Net enrolment rate(%) of Panama in 2005 to that in 2013?
Keep it short and to the point. 1.06. What is the ratio of the Net enrolment rate(%) in Small states in 2006 to that in 2012?
Your response must be concise. 0.97. What is the ratio of the Net enrolment rate(%) in Mauritania in 2006 to that in 2012?
Make the answer very short. 1.03. What is the ratio of the Net enrolment rate(%) of Panama in 2006 to that in 2012?
Make the answer very short. 1.06. What is the ratio of the Net enrolment rate(%) of Small states in 2006 to that in 2013?
Your response must be concise. 0.98. What is the ratio of the Net enrolment rate(%) of Netherlands in 2006 to that in 2013?
Offer a terse response. 1.01. What is the ratio of the Net enrolment rate(%) in Panama in 2006 to that in 2013?
Keep it short and to the point. 1.06. What is the ratio of the Net enrolment rate(%) of Small states in 2012 to that in 2013?
Your answer should be compact. 1.01. What is the ratio of the Net enrolment rate(%) in Mauritania in 2012 to that in 2013?
Ensure brevity in your answer.  0.96. What is the ratio of the Net enrolment rate(%) of Netherlands in 2012 to that in 2013?
Ensure brevity in your answer.  1.02. What is the ratio of the Net enrolment rate(%) of Panama in 2012 to that in 2013?
Give a very brief answer. 1.01. What is the difference between the highest and the second highest Net enrolment rate(%) in Small states?
Provide a succinct answer. 0.99. What is the difference between the highest and the second highest Net enrolment rate(%) of Mauritania?
Offer a very short reply. 0.69. What is the difference between the highest and the second highest Net enrolment rate(%) in Netherlands?
Give a very brief answer. 0.15. What is the difference between the highest and the second highest Net enrolment rate(%) of Panama?
Give a very brief answer. 0.44. What is the difference between the highest and the lowest Net enrolment rate(%) in Small states?
Your answer should be very brief. 5.98. What is the difference between the highest and the lowest Net enrolment rate(%) in Mauritania?
Make the answer very short. 16.03. What is the difference between the highest and the lowest Net enrolment rate(%) in Netherlands?
Provide a short and direct response. 1.73. What is the difference between the highest and the lowest Net enrolment rate(%) of Panama?
Your answer should be compact. 6.09. 